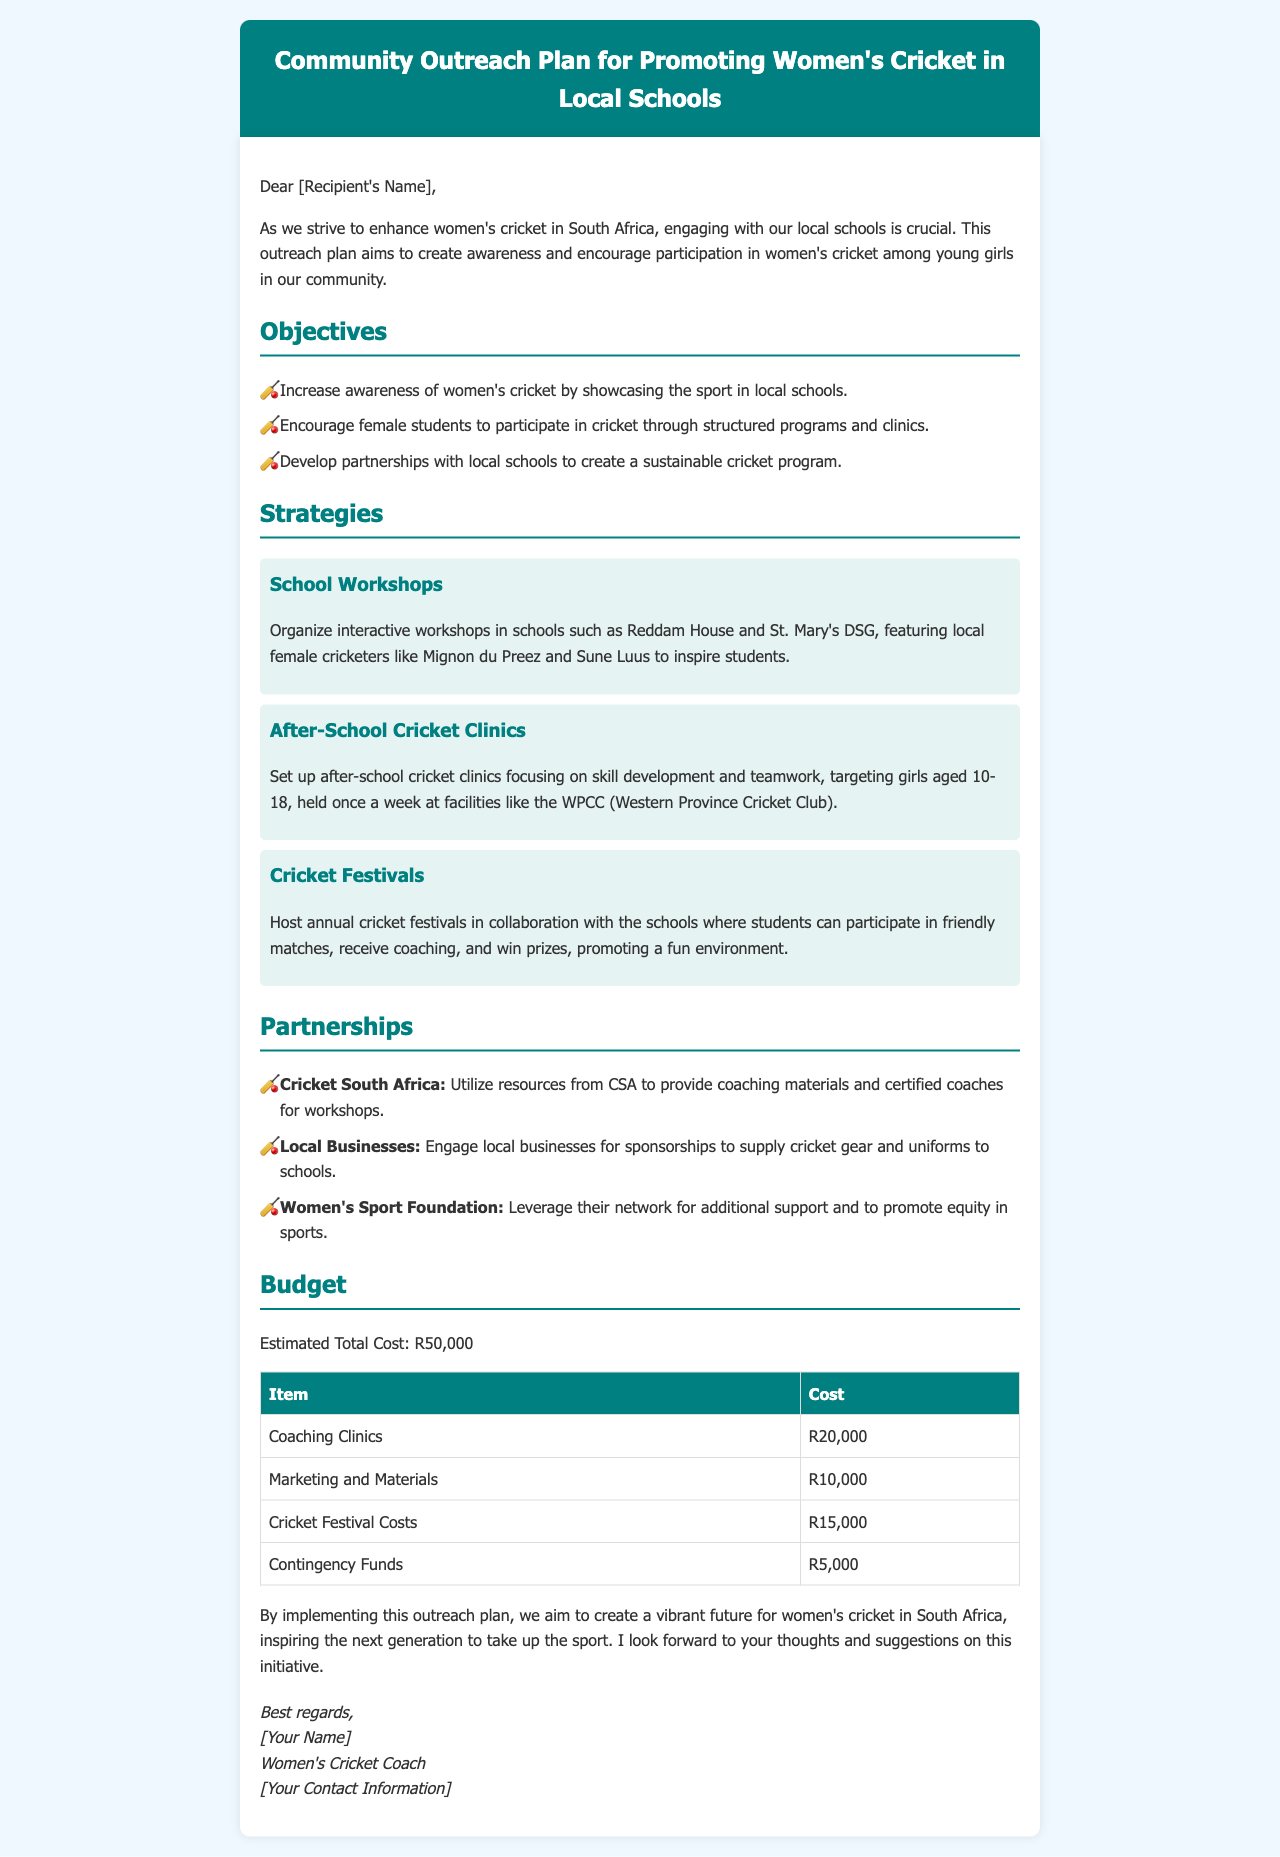What are the main objectives of the outreach plan? The objectives are to increase awareness, encourage participation, and develop partnerships in women's cricket.
Answer: Increase awareness, encourage participation, develop partnerships Who are the local female cricketers mentioned in the workshops? The email names specific cricketers who will be featured in the workshops to inspire students.
Answer: Mignon du Preez, Sune Luus How much is allocated for coaching clinics in the budget? The budget outlines specific costs for each item, indicating how much is dedicated to coaching clinics.
Answer: R20,000 What is the estimated total cost of the outreach plan? The total cost is explicitly stated in the budget section of the email.
Answer: R50,000 How often will the after-school cricket clinics be held? The document specifies the frequency at which the clinics will occur as part of the outreach strategies.
Answer: Once a week What partnerships are mentioned in the document? The email lists various organizations and businesses that will be engaged as part of the outreach efforts.
Answer: Cricket South Africa, Local Businesses, Women's Sport Foundation What specific events are planned for the cricket festivals? The outreach plan details specific activities meant to promote engagement at the cricket festivals.
Answer: Friendly matches, coaching, prizes How does the Women's Sport Foundation contribute to this initiative? The document discusses the role of the Women's Sport Foundation in supporting equity in sports.
Answer: Additional support, promote equity in sports 